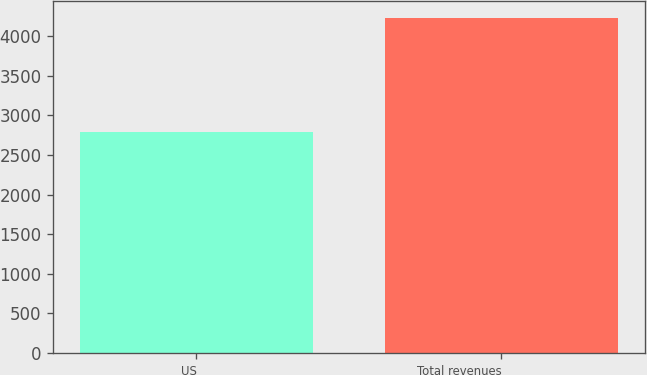<chart> <loc_0><loc_0><loc_500><loc_500><bar_chart><fcel>US<fcel>Total revenues<nl><fcel>2784<fcel>4235<nl></chart> 